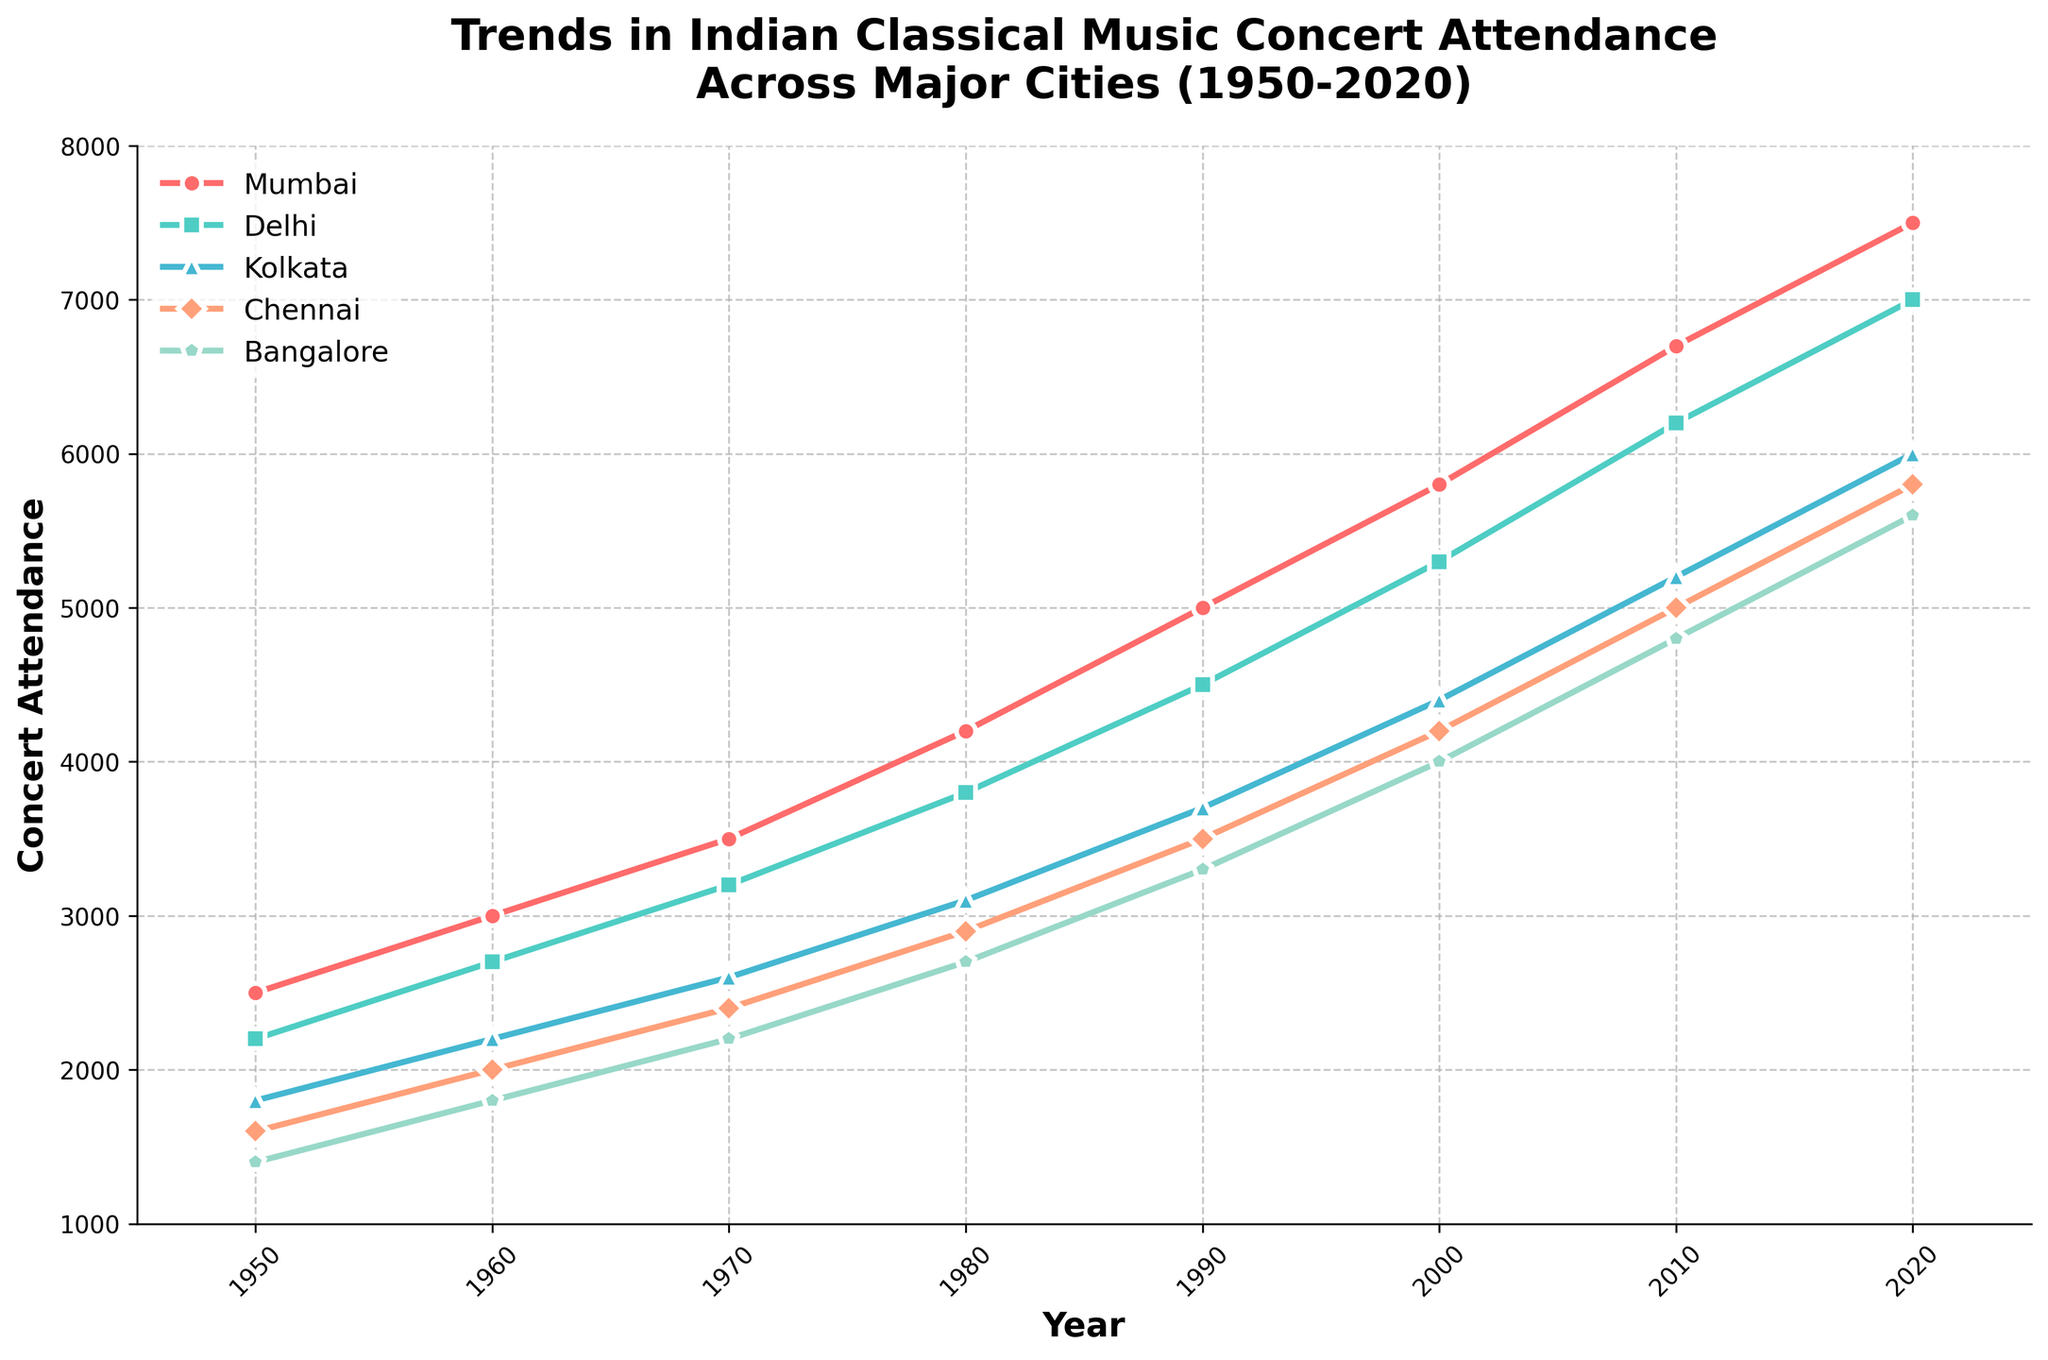Which city had the highest concert attendance in 2020? By looking at the year 2020 in the figure, the city with the highest concert attendance can be identified as the one with the highest point. Mumbai has the highest point visually.
Answer: Mumbai Which city showed the least increase in concert attendance between 1950 and 2020? To determine the city with the least increase, calculate the difference in attendance from 1950 to 2020 for each city: 
Mumbai: 7500 - 2500 = 5000
Delhi: 7000 - 2200 = 4800
Kolkata: 6000 - 1800 = 4200
Chennai: 5800 - 1600 = 4200
Bangalore: 5600 - 1400 = 4200
The city with the smallest increase is Kolkata, Chennai, and Bangalore with 4200.
Answer: Kolkata/Chennai/Bangalore Between which two consecutive decades did Mumbai's concert attendance increase the most? To find the largest increase, compute the differences between each consecutive decade for Mumbai:
1960-1950: 3000 - 2500 = 500
1970-1960: 3500 - 3000 = 500
1980-1970: 4200 - 3500 = 700
1990-1980: 5000 - 4200 = 800
2000-1990: 5800 - 5000 = 800
2010-2000: 6700 - 5800 = 900
2020-2010: 7500 - 6700 = 800
The largest increase occurred between 2010-2020 with an increase of 900.
Answer: 2010-2020 Which city had the highest average concert attendance over the entire period? To find the highest average concert attendance, calculate the average for each city:
Mumbai: (2500 + 3000 + 3500 + 4200 + 5000 + 5800 + 6700 + 7500) / 8 = 4825
Delhi: (2200 + 2700 + 3200 + 3800 + 4500 + 5300 + 6200 + 7000) / 8 = 4362.5
Kolkata: (1800 + 2200 + 2600 + 3100 + 3700 + 4400 + 5200 + 6000) / 8 = 3875
Chennai: (1600 + 2000 + 2400 + 2900 + 3500 + 4200 + 5000 + 5800) / 8 = 3437.5
Bangalore: (1400 + 1800 + 2200 + 2700 + 3300 + 4000 + 4800 + 5600) / 8 = 3225
Mumbai has the highest average attendance of 4825.
Answer: Mumbai In which decade did Kolkata surpass Chennai in terms of concert attendance? Compare the concert attendance of Kolkata and Chennai for each decade and check the first decade where Kolkata's attendance exceeded Chennai's:
1950: Kolkata: 1800, Chennai: 1600 - Kolkata is higher (not yet surpassed)
1960: Kolkata: 2200, Chennai: 2000 - Kolkata is higher
Kolkata first surpassed Chennai in 1950.
Answer: 1950 How does the trend of concert attendance in Bangalore compare to that in Delhi from 2000 to 2020? Analyze and compare the trends visually from 2000 to 2020 for Bangalore and Delhi. Both cities show an upward trend, however, the increase in Delhi is steeper than Bangalore.
Bangalore 2000-2020: 4000 to 5600, increase of 1600
Delhi 2000-2020: 5300 to 7000, increase of 1700
Delhi shows a slightly sharper increase in concert attendance compared to Bangalore over this period.
Answer: Delhi’s increase is sharper By how much did the concert attendance in Delhi fall behind Mumbai's in 1980? Subtract the concert attendance in Delhi from that in Mumbai for 1980:
Mumbai: 4200, Delhi: 3800
Difference: 4200 - 3800 = 400
Answer: 400 What is the overall trend of concert attendance across all cities from 1950 to 2020? Observing the plot, there is a consistent upward trend in concert attendance across all cities from 1950 to 2020. Every city's attendance increases as the years progress.
Answer: Increasing Which city exhibited the steepest growth in concert attendance between 1950 and 2020? To determine the steepest growth, calculate the total increase for each city and compare:
Mumbai: 7500 - 2500 = 5000
Delhi: 7000 - 2200 = 4800
Kolkata: 6000 - 1800 = 4200
Chennai: 5800 - 1600 = 4200
Bangalore: 5600 - 1400 = 4200
Mumbai exhibits the steepest growth with a total increase of 5000 attendees.
Answer: Mumbai 